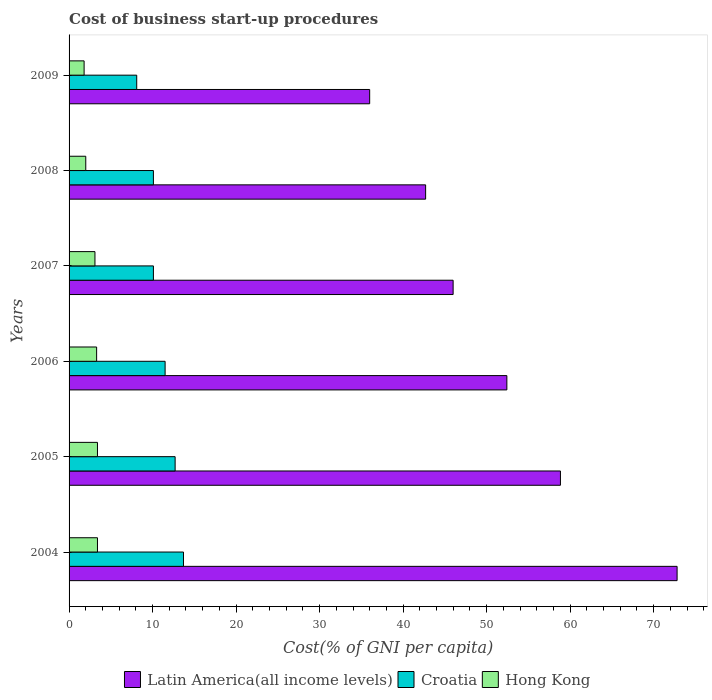How many different coloured bars are there?
Your answer should be very brief. 3. How many groups of bars are there?
Ensure brevity in your answer.  6. Are the number of bars on each tick of the Y-axis equal?
Offer a very short reply. Yes. How many bars are there on the 2nd tick from the bottom?
Ensure brevity in your answer.  3. What is the label of the 5th group of bars from the top?
Your response must be concise. 2005. In how many cases, is the number of bars for a given year not equal to the number of legend labels?
Keep it short and to the point. 0. What is the cost of business start-up procedures in Croatia in 2008?
Offer a terse response. 10.1. Across all years, what is the maximum cost of business start-up procedures in Latin America(all income levels)?
Your response must be concise. 72.81. Across all years, what is the minimum cost of business start-up procedures in Latin America(all income levels)?
Your response must be concise. 36. What is the difference between the cost of business start-up procedures in Latin America(all income levels) in 2005 and that in 2007?
Keep it short and to the point. 12.85. What is the difference between the cost of business start-up procedures in Croatia in 2004 and the cost of business start-up procedures in Latin America(all income levels) in 2009?
Give a very brief answer. -22.3. What is the average cost of business start-up procedures in Croatia per year?
Provide a succinct answer. 11.03. In the year 2005, what is the difference between the cost of business start-up procedures in Croatia and cost of business start-up procedures in Latin America(all income levels)?
Your answer should be very brief. -46.14. In how many years, is the cost of business start-up procedures in Hong Kong greater than 56 %?
Your answer should be compact. 0. What is the ratio of the cost of business start-up procedures in Croatia in 2004 to that in 2007?
Offer a terse response. 1.36. Is the cost of business start-up procedures in Hong Kong in 2005 less than that in 2009?
Your answer should be compact. No. What is the difference between the highest and the second highest cost of business start-up procedures in Latin America(all income levels)?
Your answer should be very brief. 13.97. What is the difference between the highest and the lowest cost of business start-up procedures in Hong Kong?
Make the answer very short. 1.6. What does the 3rd bar from the top in 2005 represents?
Make the answer very short. Latin America(all income levels). What does the 1st bar from the bottom in 2004 represents?
Your answer should be very brief. Latin America(all income levels). Is it the case that in every year, the sum of the cost of business start-up procedures in Latin America(all income levels) and cost of business start-up procedures in Croatia is greater than the cost of business start-up procedures in Hong Kong?
Offer a terse response. Yes. How many bars are there?
Your answer should be very brief. 18. Are all the bars in the graph horizontal?
Provide a succinct answer. Yes. Are the values on the major ticks of X-axis written in scientific E-notation?
Keep it short and to the point. No. Does the graph contain grids?
Your answer should be compact. No. Where does the legend appear in the graph?
Your response must be concise. Bottom center. How are the legend labels stacked?
Offer a very short reply. Horizontal. What is the title of the graph?
Provide a succinct answer. Cost of business start-up procedures. What is the label or title of the X-axis?
Make the answer very short. Cost(% of GNI per capita). What is the Cost(% of GNI per capita) of Latin America(all income levels) in 2004?
Give a very brief answer. 72.81. What is the Cost(% of GNI per capita) in Croatia in 2004?
Provide a short and direct response. 13.7. What is the Cost(% of GNI per capita) of Hong Kong in 2004?
Your answer should be very brief. 3.4. What is the Cost(% of GNI per capita) of Latin America(all income levels) in 2005?
Keep it short and to the point. 58.84. What is the Cost(% of GNI per capita) in Croatia in 2005?
Give a very brief answer. 12.7. What is the Cost(% of GNI per capita) in Latin America(all income levels) in 2006?
Offer a very short reply. 52.42. What is the Cost(% of GNI per capita) of Croatia in 2006?
Give a very brief answer. 11.5. What is the Cost(% of GNI per capita) of Latin America(all income levels) in 2007?
Your response must be concise. 45.99. What is the Cost(% of GNI per capita) in Croatia in 2007?
Your answer should be very brief. 10.1. What is the Cost(% of GNI per capita) of Hong Kong in 2007?
Provide a succinct answer. 3.1. What is the Cost(% of GNI per capita) of Latin America(all income levels) in 2008?
Provide a succinct answer. 42.7. What is the Cost(% of GNI per capita) in Croatia in 2008?
Offer a very short reply. 10.1. What is the Cost(% of GNI per capita) of Hong Kong in 2008?
Your response must be concise. 2. What is the Cost(% of GNI per capita) in Latin America(all income levels) in 2009?
Offer a very short reply. 36. What is the Cost(% of GNI per capita) of Croatia in 2009?
Your response must be concise. 8.1. Across all years, what is the maximum Cost(% of GNI per capita) of Latin America(all income levels)?
Give a very brief answer. 72.81. Across all years, what is the maximum Cost(% of GNI per capita) of Croatia?
Provide a succinct answer. 13.7. Across all years, what is the maximum Cost(% of GNI per capita) of Hong Kong?
Ensure brevity in your answer.  3.4. Across all years, what is the minimum Cost(% of GNI per capita) in Latin America(all income levels)?
Offer a terse response. 36. Across all years, what is the minimum Cost(% of GNI per capita) in Croatia?
Provide a succinct answer. 8.1. What is the total Cost(% of GNI per capita) of Latin America(all income levels) in the graph?
Ensure brevity in your answer.  308.76. What is the total Cost(% of GNI per capita) in Croatia in the graph?
Provide a succinct answer. 66.2. What is the difference between the Cost(% of GNI per capita) of Latin America(all income levels) in 2004 and that in 2005?
Your response must be concise. 13.97. What is the difference between the Cost(% of GNI per capita) of Hong Kong in 2004 and that in 2005?
Your answer should be compact. 0. What is the difference between the Cost(% of GNI per capita) of Latin America(all income levels) in 2004 and that in 2006?
Provide a short and direct response. 20.39. What is the difference between the Cost(% of GNI per capita) in Croatia in 2004 and that in 2006?
Keep it short and to the point. 2.2. What is the difference between the Cost(% of GNI per capita) of Hong Kong in 2004 and that in 2006?
Make the answer very short. 0.1. What is the difference between the Cost(% of GNI per capita) in Latin America(all income levels) in 2004 and that in 2007?
Your answer should be compact. 26.82. What is the difference between the Cost(% of GNI per capita) in Croatia in 2004 and that in 2007?
Offer a very short reply. 3.6. What is the difference between the Cost(% of GNI per capita) in Latin America(all income levels) in 2004 and that in 2008?
Offer a very short reply. 30.11. What is the difference between the Cost(% of GNI per capita) in Hong Kong in 2004 and that in 2008?
Offer a very short reply. 1.4. What is the difference between the Cost(% of GNI per capita) of Latin America(all income levels) in 2004 and that in 2009?
Provide a short and direct response. 36.81. What is the difference between the Cost(% of GNI per capita) in Croatia in 2004 and that in 2009?
Your answer should be very brief. 5.6. What is the difference between the Cost(% of GNI per capita) of Latin America(all income levels) in 2005 and that in 2006?
Your answer should be very brief. 6.42. What is the difference between the Cost(% of GNI per capita) in Hong Kong in 2005 and that in 2006?
Keep it short and to the point. 0.1. What is the difference between the Cost(% of GNI per capita) of Latin America(all income levels) in 2005 and that in 2007?
Ensure brevity in your answer.  12.85. What is the difference between the Cost(% of GNI per capita) in Croatia in 2005 and that in 2007?
Ensure brevity in your answer.  2.6. What is the difference between the Cost(% of GNI per capita) in Latin America(all income levels) in 2005 and that in 2008?
Offer a very short reply. 16.14. What is the difference between the Cost(% of GNI per capita) in Croatia in 2005 and that in 2008?
Keep it short and to the point. 2.6. What is the difference between the Cost(% of GNI per capita) in Hong Kong in 2005 and that in 2008?
Your answer should be compact. 1.4. What is the difference between the Cost(% of GNI per capita) of Latin America(all income levels) in 2005 and that in 2009?
Your response must be concise. 22.84. What is the difference between the Cost(% of GNI per capita) in Croatia in 2005 and that in 2009?
Keep it short and to the point. 4.6. What is the difference between the Cost(% of GNI per capita) in Latin America(all income levels) in 2006 and that in 2007?
Give a very brief answer. 6.43. What is the difference between the Cost(% of GNI per capita) of Croatia in 2006 and that in 2007?
Your answer should be very brief. 1.4. What is the difference between the Cost(% of GNI per capita) of Hong Kong in 2006 and that in 2007?
Provide a short and direct response. 0.2. What is the difference between the Cost(% of GNI per capita) of Latin America(all income levels) in 2006 and that in 2008?
Your answer should be compact. 9.73. What is the difference between the Cost(% of GNI per capita) of Croatia in 2006 and that in 2008?
Your answer should be compact. 1.4. What is the difference between the Cost(% of GNI per capita) in Latin America(all income levels) in 2006 and that in 2009?
Make the answer very short. 16.43. What is the difference between the Cost(% of GNI per capita) in Latin America(all income levels) in 2007 and that in 2008?
Your answer should be very brief. 3.29. What is the difference between the Cost(% of GNI per capita) in Croatia in 2007 and that in 2008?
Ensure brevity in your answer.  0. What is the difference between the Cost(% of GNI per capita) in Hong Kong in 2007 and that in 2008?
Your response must be concise. 1.1. What is the difference between the Cost(% of GNI per capita) of Latin America(all income levels) in 2007 and that in 2009?
Keep it short and to the point. 9.99. What is the difference between the Cost(% of GNI per capita) in Hong Kong in 2007 and that in 2009?
Provide a short and direct response. 1.3. What is the difference between the Cost(% of GNI per capita) of Latin America(all income levels) in 2008 and that in 2009?
Offer a terse response. 6.7. What is the difference between the Cost(% of GNI per capita) in Hong Kong in 2008 and that in 2009?
Offer a terse response. 0.2. What is the difference between the Cost(% of GNI per capita) in Latin America(all income levels) in 2004 and the Cost(% of GNI per capita) in Croatia in 2005?
Ensure brevity in your answer.  60.11. What is the difference between the Cost(% of GNI per capita) of Latin America(all income levels) in 2004 and the Cost(% of GNI per capita) of Hong Kong in 2005?
Ensure brevity in your answer.  69.41. What is the difference between the Cost(% of GNI per capita) in Latin America(all income levels) in 2004 and the Cost(% of GNI per capita) in Croatia in 2006?
Your answer should be very brief. 61.31. What is the difference between the Cost(% of GNI per capita) of Latin America(all income levels) in 2004 and the Cost(% of GNI per capita) of Hong Kong in 2006?
Provide a succinct answer. 69.51. What is the difference between the Cost(% of GNI per capita) in Croatia in 2004 and the Cost(% of GNI per capita) in Hong Kong in 2006?
Provide a succinct answer. 10.4. What is the difference between the Cost(% of GNI per capita) in Latin America(all income levels) in 2004 and the Cost(% of GNI per capita) in Croatia in 2007?
Ensure brevity in your answer.  62.71. What is the difference between the Cost(% of GNI per capita) of Latin America(all income levels) in 2004 and the Cost(% of GNI per capita) of Hong Kong in 2007?
Your answer should be compact. 69.71. What is the difference between the Cost(% of GNI per capita) in Croatia in 2004 and the Cost(% of GNI per capita) in Hong Kong in 2007?
Make the answer very short. 10.6. What is the difference between the Cost(% of GNI per capita) of Latin America(all income levels) in 2004 and the Cost(% of GNI per capita) of Croatia in 2008?
Ensure brevity in your answer.  62.71. What is the difference between the Cost(% of GNI per capita) of Latin America(all income levels) in 2004 and the Cost(% of GNI per capita) of Hong Kong in 2008?
Your answer should be compact. 70.81. What is the difference between the Cost(% of GNI per capita) of Latin America(all income levels) in 2004 and the Cost(% of GNI per capita) of Croatia in 2009?
Give a very brief answer. 64.71. What is the difference between the Cost(% of GNI per capita) in Latin America(all income levels) in 2004 and the Cost(% of GNI per capita) in Hong Kong in 2009?
Provide a succinct answer. 71.01. What is the difference between the Cost(% of GNI per capita) of Croatia in 2004 and the Cost(% of GNI per capita) of Hong Kong in 2009?
Offer a terse response. 11.9. What is the difference between the Cost(% of GNI per capita) in Latin America(all income levels) in 2005 and the Cost(% of GNI per capita) in Croatia in 2006?
Your answer should be compact. 47.34. What is the difference between the Cost(% of GNI per capita) in Latin America(all income levels) in 2005 and the Cost(% of GNI per capita) in Hong Kong in 2006?
Make the answer very short. 55.54. What is the difference between the Cost(% of GNI per capita) of Croatia in 2005 and the Cost(% of GNI per capita) of Hong Kong in 2006?
Your answer should be compact. 9.4. What is the difference between the Cost(% of GNI per capita) of Latin America(all income levels) in 2005 and the Cost(% of GNI per capita) of Croatia in 2007?
Provide a succinct answer. 48.74. What is the difference between the Cost(% of GNI per capita) in Latin America(all income levels) in 2005 and the Cost(% of GNI per capita) in Hong Kong in 2007?
Offer a terse response. 55.74. What is the difference between the Cost(% of GNI per capita) in Croatia in 2005 and the Cost(% of GNI per capita) in Hong Kong in 2007?
Keep it short and to the point. 9.6. What is the difference between the Cost(% of GNI per capita) in Latin America(all income levels) in 2005 and the Cost(% of GNI per capita) in Croatia in 2008?
Your answer should be compact. 48.74. What is the difference between the Cost(% of GNI per capita) in Latin America(all income levels) in 2005 and the Cost(% of GNI per capita) in Hong Kong in 2008?
Your response must be concise. 56.84. What is the difference between the Cost(% of GNI per capita) in Latin America(all income levels) in 2005 and the Cost(% of GNI per capita) in Croatia in 2009?
Offer a very short reply. 50.74. What is the difference between the Cost(% of GNI per capita) of Latin America(all income levels) in 2005 and the Cost(% of GNI per capita) of Hong Kong in 2009?
Provide a succinct answer. 57.04. What is the difference between the Cost(% of GNI per capita) of Croatia in 2005 and the Cost(% of GNI per capita) of Hong Kong in 2009?
Make the answer very short. 10.9. What is the difference between the Cost(% of GNI per capita) of Latin America(all income levels) in 2006 and the Cost(% of GNI per capita) of Croatia in 2007?
Your answer should be very brief. 42.32. What is the difference between the Cost(% of GNI per capita) in Latin America(all income levels) in 2006 and the Cost(% of GNI per capita) in Hong Kong in 2007?
Provide a succinct answer. 49.32. What is the difference between the Cost(% of GNI per capita) in Croatia in 2006 and the Cost(% of GNI per capita) in Hong Kong in 2007?
Keep it short and to the point. 8.4. What is the difference between the Cost(% of GNI per capita) of Latin America(all income levels) in 2006 and the Cost(% of GNI per capita) of Croatia in 2008?
Provide a short and direct response. 42.32. What is the difference between the Cost(% of GNI per capita) in Latin America(all income levels) in 2006 and the Cost(% of GNI per capita) in Hong Kong in 2008?
Provide a short and direct response. 50.42. What is the difference between the Cost(% of GNI per capita) of Croatia in 2006 and the Cost(% of GNI per capita) of Hong Kong in 2008?
Ensure brevity in your answer.  9.5. What is the difference between the Cost(% of GNI per capita) in Latin America(all income levels) in 2006 and the Cost(% of GNI per capita) in Croatia in 2009?
Your response must be concise. 44.32. What is the difference between the Cost(% of GNI per capita) of Latin America(all income levels) in 2006 and the Cost(% of GNI per capita) of Hong Kong in 2009?
Give a very brief answer. 50.62. What is the difference between the Cost(% of GNI per capita) of Latin America(all income levels) in 2007 and the Cost(% of GNI per capita) of Croatia in 2008?
Your response must be concise. 35.89. What is the difference between the Cost(% of GNI per capita) in Latin America(all income levels) in 2007 and the Cost(% of GNI per capita) in Hong Kong in 2008?
Your answer should be compact. 43.99. What is the difference between the Cost(% of GNI per capita) in Croatia in 2007 and the Cost(% of GNI per capita) in Hong Kong in 2008?
Offer a terse response. 8.1. What is the difference between the Cost(% of GNI per capita) in Latin America(all income levels) in 2007 and the Cost(% of GNI per capita) in Croatia in 2009?
Keep it short and to the point. 37.89. What is the difference between the Cost(% of GNI per capita) of Latin America(all income levels) in 2007 and the Cost(% of GNI per capita) of Hong Kong in 2009?
Provide a succinct answer. 44.19. What is the difference between the Cost(% of GNI per capita) of Croatia in 2007 and the Cost(% of GNI per capita) of Hong Kong in 2009?
Your answer should be very brief. 8.3. What is the difference between the Cost(% of GNI per capita) of Latin America(all income levels) in 2008 and the Cost(% of GNI per capita) of Croatia in 2009?
Provide a succinct answer. 34.6. What is the difference between the Cost(% of GNI per capita) in Latin America(all income levels) in 2008 and the Cost(% of GNI per capita) in Hong Kong in 2009?
Offer a very short reply. 40.9. What is the difference between the Cost(% of GNI per capita) in Croatia in 2008 and the Cost(% of GNI per capita) in Hong Kong in 2009?
Ensure brevity in your answer.  8.3. What is the average Cost(% of GNI per capita) of Latin America(all income levels) per year?
Provide a short and direct response. 51.46. What is the average Cost(% of GNI per capita) of Croatia per year?
Provide a short and direct response. 11.03. What is the average Cost(% of GNI per capita) of Hong Kong per year?
Your response must be concise. 2.83. In the year 2004, what is the difference between the Cost(% of GNI per capita) of Latin America(all income levels) and Cost(% of GNI per capita) of Croatia?
Keep it short and to the point. 59.11. In the year 2004, what is the difference between the Cost(% of GNI per capita) in Latin America(all income levels) and Cost(% of GNI per capita) in Hong Kong?
Your response must be concise. 69.41. In the year 2005, what is the difference between the Cost(% of GNI per capita) of Latin America(all income levels) and Cost(% of GNI per capita) of Croatia?
Make the answer very short. 46.14. In the year 2005, what is the difference between the Cost(% of GNI per capita) of Latin America(all income levels) and Cost(% of GNI per capita) of Hong Kong?
Offer a very short reply. 55.44. In the year 2005, what is the difference between the Cost(% of GNI per capita) of Croatia and Cost(% of GNI per capita) of Hong Kong?
Make the answer very short. 9.3. In the year 2006, what is the difference between the Cost(% of GNI per capita) in Latin America(all income levels) and Cost(% of GNI per capita) in Croatia?
Provide a succinct answer. 40.92. In the year 2006, what is the difference between the Cost(% of GNI per capita) in Latin America(all income levels) and Cost(% of GNI per capita) in Hong Kong?
Your answer should be compact. 49.12. In the year 2007, what is the difference between the Cost(% of GNI per capita) in Latin America(all income levels) and Cost(% of GNI per capita) in Croatia?
Provide a succinct answer. 35.89. In the year 2007, what is the difference between the Cost(% of GNI per capita) of Latin America(all income levels) and Cost(% of GNI per capita) of Hong Kong?
Offer a terse response. 42.89. In the year 2008, what is the difference between the Cost(% of GNI per capita) in Latin America(all income levels) and Cost(% of GNI per capita) in Croatia?
Your answer should be compact. 32.6. In the year 2008, what is the difference between the Cost(% of GNI per capita) in Latin America(all income levels) and Cost(% of GNI per capita) in Hong Kong?
Offer a terse response. 40.7. In the year 2008, what is the difference between the Cost(% of GNI per capita) of Croatia and Cost(% of GNI per capita) of Hong Kong?
Your response must be concise. 8.1. In the year 2009, what is the difference between the Cost(% of GNI per capita) of Latin America(all income levels) and Cost(% of GNI per capita) of Croatia?
Your response must be concise. 27.9. In the year 2009, what is the difference between the Cost(% of GNI per capita) in Latin America(all income levels) and Cost(% of GNI per capita) in Hong Kong?
Your answer should be compact. 34.2. What is the ratio of the Cost(% of GNI per capita) of Latin America(all income levels) in 2004 to that in 2005?
Your answer should be compact. 1.24. What is the ratio of the Cost(% of GNI per capita) of Croatia in 2004 to that in 2005?
Provide a succinct answer. 1.08. What is the ratio of the Cost(% of GNI per capita) of Latin America(all income levels) in 2004 to that in 2006?
Offer a very short reply. 1.39. What is the ratio of the Cost(% of GNI per capita) of Croatia in 2004 to that in 2006?
Offer a terse response. 1.19. What is the ratio of the Cost(% of GNI per capita) of Hong Kong in 2004 to that in 2006?
Offer a terse response. 1.03. What is the ratio of the Cost(% of GNI per capita) of Latin America(all income levels) in 2004 to that in 2007?
Give a very brief answer. 1.58. What is the ratio of the Cost(% of GNI per capita) in Croatia in 2004 to that in 2007?
Your answer should be very brief. 1.36. What is the ratio of the Cost(% of GNI per capita) of Hong Kong in 2004 to that in 2007?
Your answer should be very brief. 1.1. What is the ratio of the Cost(% of GNI per capita) of Latin America(all income levels) in 2004 to that in 2008?
Your answer should be very brief. 1.71. What is the ratio of the Cost(% of GNI per capita) of Croatia in 2004 to that in 2008?
Make the answer very short. 1.36. What is the ratio of the Cost(% of GNI per capita) in Latin America(all income levels) in 2004 to that in 2009?
Offer a terse response. 2.02. What is the ratio of the Cost(% of GNI per capita) of Croatia in 2004 to that in 2009?
Offer a very short reply. 1.69. What is the ratio of the Cost(% of GNI per capita) in Hong Kong in 2004 to that in 2009?
Your answer should be compact. 1.89. What is the ratio of the Cost(% of GNI per capita) in Latin America(all income levels) in 2005 to that in 2006?
Offer a very short reply. 1.12. What is the ratio of the Cost(% of GNI per capita) of Croatia in 2005 to that in 2006?
Give a very brief answer. 1.1. What is the ratio of the Cost(% of GNI per capita) of Hong Kong in 2005 to that in 2006?
Your answer should be very brief. 1.03. What is the ratio of the Cost(% of GNI per capita) in Latin America(all income levels) in 2005 to that in 2007?
Ensure brevity in your answer.  1.28. What is the ratio of the Cost(% of GNI per capita) of Croatia in 2005 to that in 2007?
Give a very brief answer. 1.26. What is the ratio of the Cost(% of GNI per capita) of Hong Kong in 2005 to that in 2007?
Your response must be concise. 1.1. What is the ratio of the Cost(% of GNI per capita) of Latin America(all income levels) in 2005 to that in 2008?
Make the answer very short. 1.38. What is the ratio of the Cost(% of GNI per capita) of Croatia in 2005 to that in 2008?
Ensure brevity in your answer.  1.26. What is the ratio of the Cost(% of GNI per capita) of Latin America(all income levels) in 2005 to that in 2009?
Ensure brevity in your answer.  1.63. What is the ratio of the Cost(% of GNI per capita) of Croatia in 2005 to that in 2009?
Offer a very short reply. 1.57. What is the ratio of the Cost(% of GNI per capita) of Hong Kong in 2005 to that in 2009?
Your answer should be compact. 1.89. What is the ratio of the Cost(% of GNI per capita) of Latin America(all income levels) in 2006 to that in 2007?
Keep it short and to the point. 1.14. What is the ratio of the Cost(% of GNI per capita) in Croatia in 2006 to that in 2007?
Ensure brevity in your answer.  1.14. What is the ratio of the Cost(% of GNI per capita) in Hong Kong in 2006 to that in 2007?
Keep it short and to the point. 1.06. What is the ratio of the Cost(% of GNI per capita) of Latin America(all income levels) in 2006 to that in 2008?
Your answer should be very brief. 1.23. What is the ratio of the Cost(% of GNI per capita) of Croatia in 2006 to that in 2008?
Your response must be concise. 1.14. What is the ratio of the Cost(% of GNI per capita) of Hong Kong in 2006 to that in 2008?
Ensure brevity in your answer.  1.65. What is the ratio of the Cost(% of GNI per capita) of Latin America(all income levels) in 2006 to that in 2009?
Give a very brief answer. 1.46. What is the ratio of the Cost(% of GNI per capita) in Croatia in 2006 to that in 2009?
Your answer should be compact. 1.42. What is the ratio of the Cost(% of GNI per capita) in Hong Kong in 2006 to that in 2009?
Offer a terse response. 1.83. What is the ratio of the Cost(% of GNI per capita) of Latin America(all income levels) in 2007 to that in 2008?
Give a very brief answer. 1.08. What is the ratio of the Cost(% of GNI per capita) of Hong Kong in 2007 to that in 2008?
Offer a very short reply. 1.55. What is the ratio of the Cost(% of GNI per capita) of Latin America(all income levels) in 2007 to that in 2009?
Offer a very short reply. 1.28. What is the ratio of the Cost(% of GNI per capita) of Croatia in 2007 to that in 2009?
Make the answer very short. 1.25. What is the ratio of the Cost(% of GNI per capita) in Hong Kong in 2007 to that in 2009?
Offer a very short reply. 1.72. What is the ratio of the Cost(% of GNI per capita) in Latin America(all income levels) in 2008 to that in 2009?
Give a very brief answer. 1.19. What is the ratio of the Cost(% of GNI per capita) of Croatia in 2008 to that in 2009?
Provide a short and direct response. 1.25. What is the ratio of the Cost(% of GNI per capita) of Hong Kong in 2008 to that in 2009?
Give a very brief answer. 1.11. What is the difference between the highest and the second highest Cost(% of GNI per capita) in Latin America(all income levels)?
Offer a terse response. 13.97. What is the difference between the highest and the second highest Cost(% of GNI per capita) of Croatia?
Keep it short and to the point. 1. What is the difference between the highest and the lowest Cost(% of GNI per capita) of Latin America(all income levels)?
Provide a succinct answer. 36.81. 